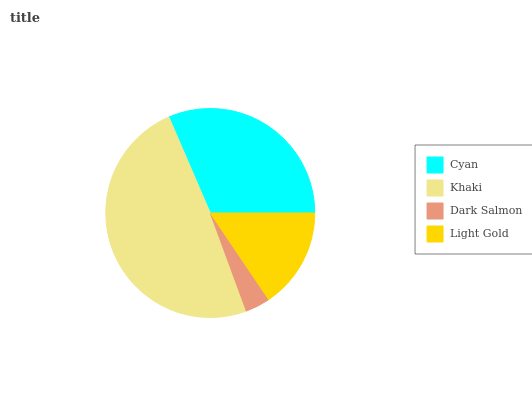Is Dark Salmon the minimum?
Answer yes or no. Yes. Is Khaki the maximum?
Answer yes or no. Yes. Is Khaki the minimum?
Answer yes or no. No. Is Dark Salmon the maximum?
Answer yes or no. No. Is Khaki greater than Dark Salmon?
Answer yes or no. Yes. Is Dark Salmon less than Khaki?
Answer yes or no. Yes. Is Dark Salmon greater than Khaki?
Answer yes or no. No. Is Khaki less than Dark Salmon?
Answer yes or no. No. Is Cyan the high median?
Answer yes or no. Yes. Is Light Gold the low median?
Answer yes or no. Yes. Is Khaki the high median?
Answer yes or no. No. Is Cyan the low median?
Answer yes or no. No. 